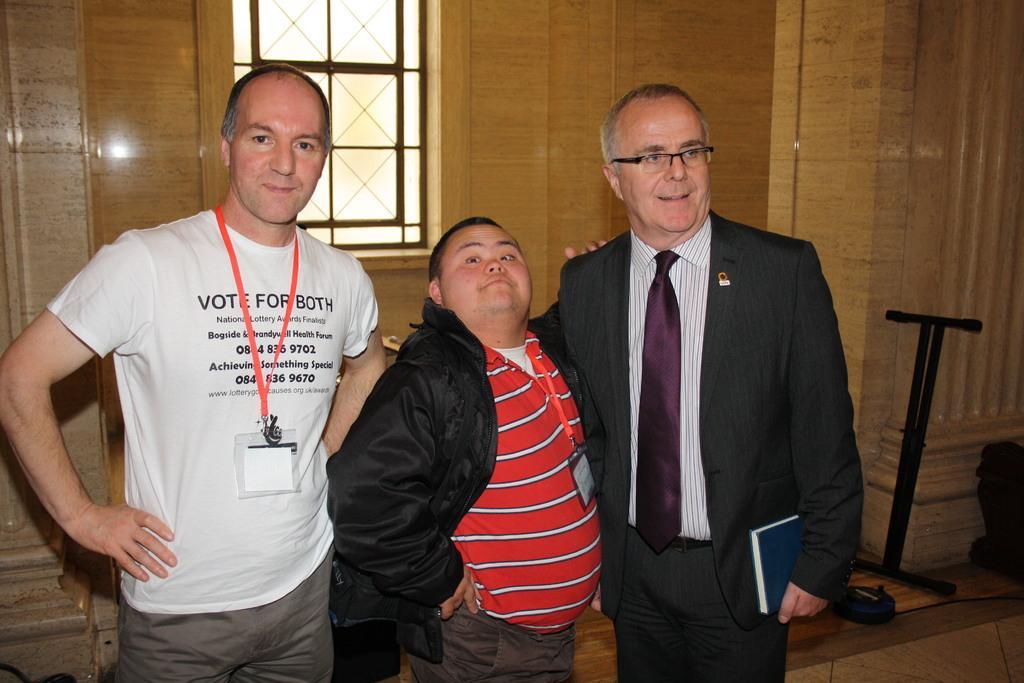Please provide a concise description of this image. In this picture we can see group of people, on the right side of the image we can see a man, he wore spectacles and he is holding a book, in the background we can see few metal rods and a window. 